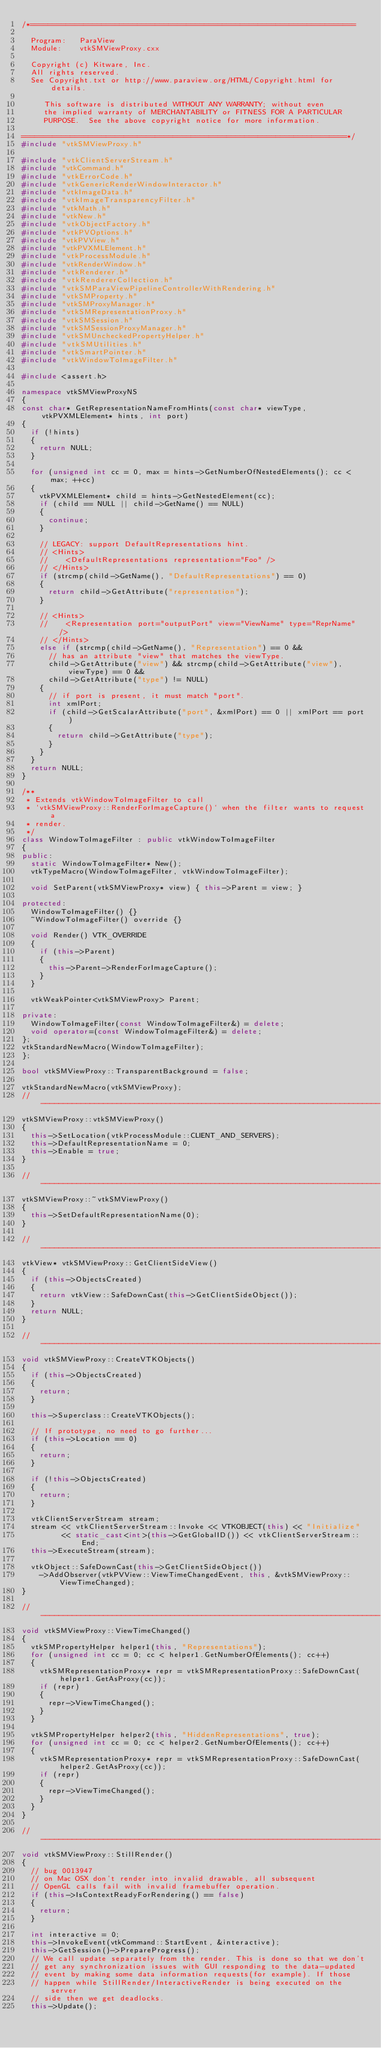Convert code to text. <code><loc_0><loc_0><loc_500><loc_500><_C++_>/*=========================================================================

  Program:   ParaView
  Module:    vtkSMViewProxy.cxx

  Copyright (c) Kitware, Inc.
  All rights reserved.
  See Copyright.txt or http://www.paraview.org/HTML/Copyright.html for details.

     This software is distributed WITHOUT ANY WARRANTY; without even
     the implied warranty of MERCHANTABILITY or FITNESS FOR A PARTICULAR
     PURPOSE.  See the above copyright notice for more information.

=========================================================================*/
#include "vtkSMViewProxy.h"

#include "vtkClientServerStream.h"
#include "vtkCommand.h"
#include "vtkErrorCode.h"
#include "vtkGenericRenderWindowInteractor.h"
#include "vtkImageData.h"
#include "vtkImageTransparencyFilter.h"
#include "vtkMath.h"
#include "vtkNew.h"
#include "vtkObjectFactory.h"
#include "vtkPVOptions.h"
#include "vtkPVView.h"
#include "vtkPVXMLElement.h"
#include "vtkProcessModule.h"
#include "vtkRenderWindow.h"
#include "vtkRenderer.h"
#include "vtkRendererCollection.h"
#include "vtkSMParaViewPipelineControllerWithRendering.h"
#include "vtkSMProperty.h"
#include "vtkSMProxyManager.h"
#include "vtkSMRepresentationProxy.h"
#include "vtkSMSession.h"
#include "vtkSMSessionProxyManager.h"
#include "vtkSMUncheckedPropertyHelper.h"
#include "vtkSMUtilities.h"
#include "vtkSmartPointer.h"
#include "vtkWindowToImageFilter.h"

#include <assert.h>

namespace vtkSMViewProxyNS
{
const char* GetRepresentationNameFromHints(const char* viewType, vtkPVXMLElement* hints, int port)
{
  if (!hints)
  {
    return NULL;
  }

  for (unsigned int cc = 0, max = hints->GetNumberOfNestedElements(); cc < max; ++cc)
  {
    vtkPVXMLElement* child = hints->GetNestedElement(cc);
    if (child == NULL || child->GetName() == NULL)
    {
      continue;
    }

    // LEGACY: support DefaultRepresentations hint.
    // <Hints>
    //    <DefaultRepresentations representation="Foo" />
    // </Hints>
    if (strcmp(child->GetName(), "DefaultRepresentations") == 0)
    {
      return child->GetAttribute("representation");
    }

    // <Hints>
    //    <Representation port="outputPort" view="ViewName" type="ReprName" />
    // </Hints>
    else if (strcmp(child->GetName(), "Representation") == 0 &&
      // has an attribute "view" that matches the viewType.
      child->GetAttribute("view") && strcmp(child->GetAttribute("view"), viewType) == 0 &&
      child->GetAttribute("type") != NULL)
    {
      // if port is present, it must match "port".
      int xmlPort;
      if (child->GetScalarAttribute("port", &xmlPort) == 0 || xmlPort == port)
      {
        return child->GetAttribute("type");
      }
    }
  }
  return NULL;
}

/**
 * Extends vtkWindowToImageFilter to call
 * `vtkSMViewProxy::RenderForImageCapture()` when the filter wants to request a
 * render.
 */
class WindowToImageFilter : public vtkWindowToImageFilter
{
public:
  static WindowToImageFilter* New();
  vtkTypeMacro(WindowToImageFilter, vtkWindowToImageFilter);

  void SetParent(vtkSMViewProxy* view) { this->Parent = view; }

protected:
  WindowToImageFilter() {}
  ~WindowToImageFilter() override {}

  void Render() VTK_OVERRIDE
  {
    if (this->Parent)
    {
      this->Parent->RenderForImageCapture();
    }
  }

  vtkWeakPointer<vtkSMViewProxy> Parent;

private:
  WindowToImageFilter(const WindowToImageFilter&) = delete;
  void operator=(const WindowToImageFilter&) = delete;
};
vtkStandardNewMacro(WindowToImageFilter);
};

bool vtkSMViewProxy::TransparentBackground = false;

vtkStandardNewMacro(vtkSMViewProxy);
//----------------------------------------------------------------------------
vtkSMViewProxy::vtkSMViewProxy()
{
  this->SetLocation(vtkProcessModule::CLIENT_AND_SERVERS);
  this->DefaultRepresentationName = 0;
  this->Enable = true;
}

//----------------------------------------------------------------------------
vtkSMViewProxy::~vtkSMViewProxy()
{
  this->SetDefaultRepresentationName(0);
}

//----------------------------------------------------------------------------
vtkView* vtkSMViewProxy::GetClientSideView()
{
  if (this->ObjectsCreated)
  {
    return vtkView::SafeDownCast(this->GetClientSideObject());
  }
  return NULL;
}

//----------------------------------------------------------------------------
void vtkSMViewProxy::CreateVTKObjects()
{
  if (this->ObjectsCreated)
  {
    return;
  }

  this->Superclass::CreateVTKObjects();

  // If prototype, no need to go further...
  if (this->Location == 0)
  {
    return;
  }

  if (!this->ObjectsCreated)
  {
    return;
  }

  vtkClientServerStream stream;
  stream << vtkClientServerStream::Invoke << VTKOBJECT(this) << "Initialize"
         << static_cast<int>(this->GetGlobalID()) << vtkClientServerStream::End;
  this->ExecuteStream(stream);

  vtkObject::SafeDownCast(this->GetClientSideObject())
    ->AddObserver(vtkPVView::ViewTimeChangedEvent, this, &vtkSMViewProxy::ViewTimeChanged);
}

//----------------------------------------------------------------------------
void vtkSMViewProxy::ViewTimeChanged()
{
  vtkSMPropertyHelper helper1(this, "Representations");
  for (unsigned int cc = 0; cc < helper1.GetNumberOfElements(); cc++)
  {
    vtkSMRepresentationProxy* repr = vtkSMRepresentationProxy::SafeDownCast(helper1.GetAsProxy(cc));
    if (repr)
    {
      repr->ViewTimeChanged();
    }
  }

  vtkSMPropertyHelper helper2(this, "HiddenRepresentations", true);
  for (unsigned int cc = 0; cc < helper2.GetNumberOfElements(); cc++)
  {
    vtkSMRepresentationProxy* repr = vtkSMRepresentationProxy::SafeDownCast(helper2.GetAsProxy(cc));
    if (repr)
    {
      repr->ViewTimeChanged();
    }
  }
}

//----------------------------------------------------------------------------
void vtkSMViewProxy::StillRender()
{
  // bug 0013947
  // on Mac OSX don't render into invalid drawable, all subsequent
  // OpenGL calls fail with invalid framebuffer operation.
  if (this->IsContextReadyForRendering() == false)
  {
    return;
  }

  int interactive = 0;
  this->InvokeEvent(vtkCommand::StartEvent, &interactive);
  this->GetSession()->PrepareProgress();
  // We call update separately from the render. This is done so that we don't
  // get any synchronization issues with GUI responding to the data-updated
  // event by making some data information requests(for example). If those
  // happen while StillRender/InteractiveRender is being executed on the server
  // side then we get deadlocks.
  this->Update();
</code> 